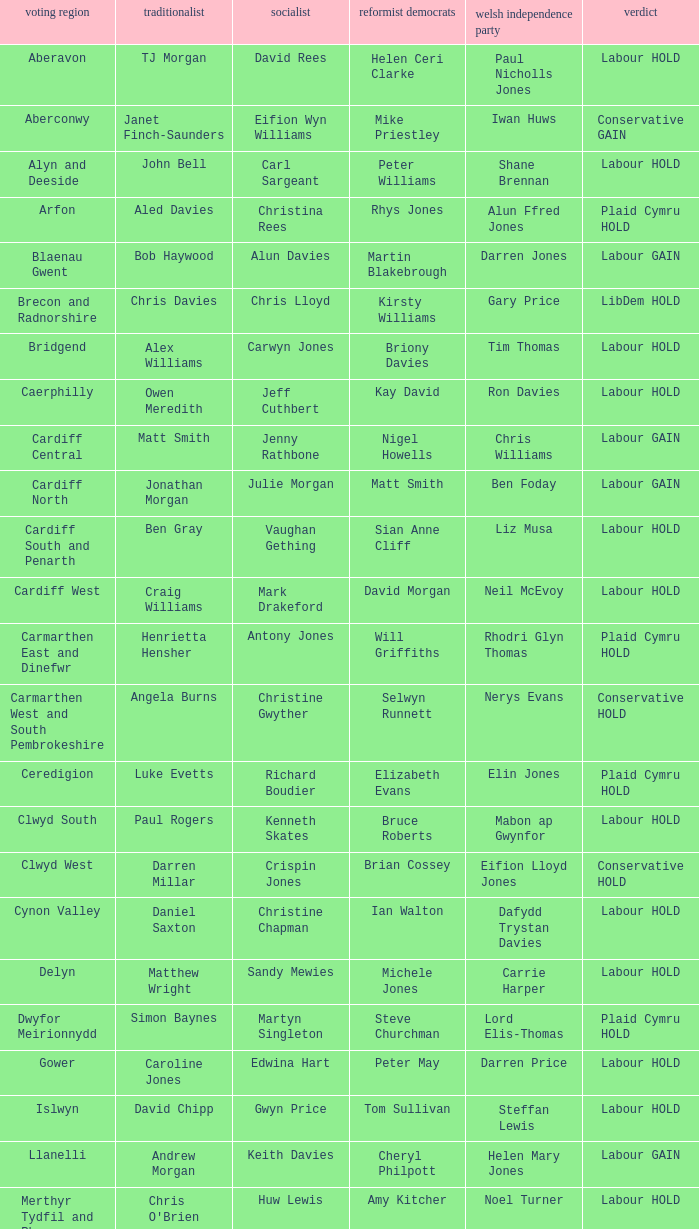In what constituency was the result labour hold and Liberal democrat Elizabeth Newton won? Newport West. 